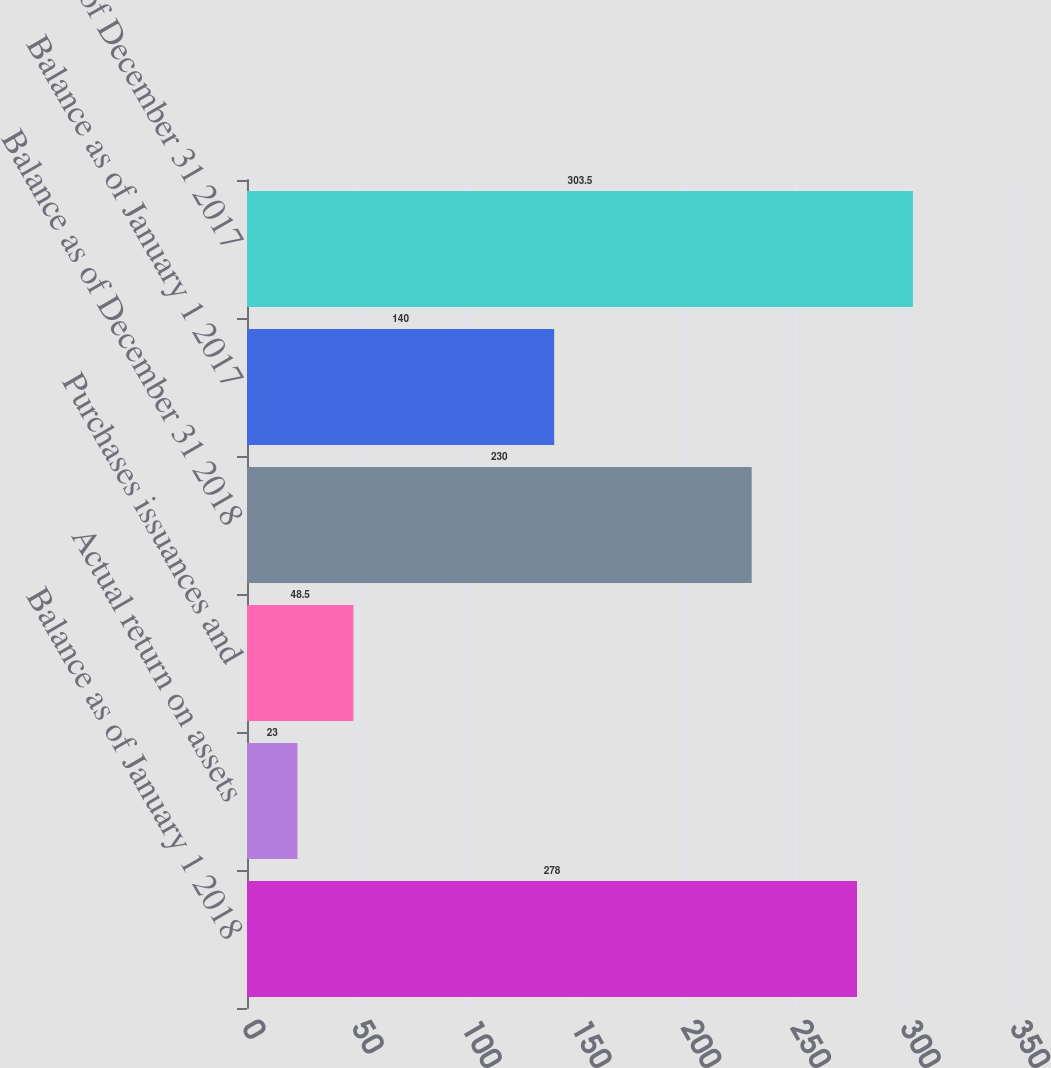Convert chart to OTSL. <chart><loc_0><loc_0><loc_500><loc_500><bar_chart><fcel>Balance as of January 1 2018<fcel>Actual return on assets<fcel>Purchases issuances and<fcel>Balance as of December 31 2018<fcel>Balance as of January 1 2017<fcel>Balance as of December 31 2017<nl><fcel>278<fcel>23<fcel>48.5<fcel>230<fcel>140<fcel>303.5<nl></chart> 